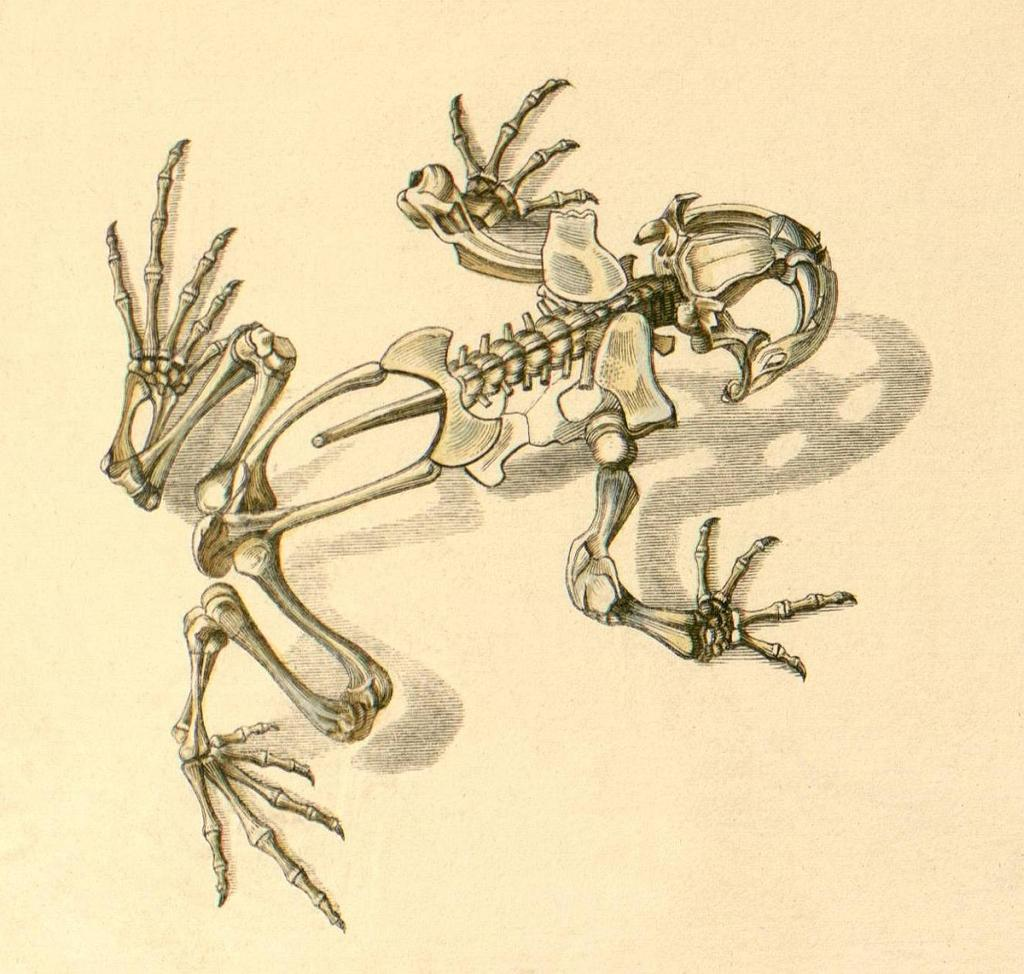What is depicted in the image? There is a drawing of a frog's skeleton in the image. What color is the background of the image? The background of the image is cream-colored. What is the reaction of the frog to the expansion of the universe in the image? There is no frog or expansion of the universe depicted in the image; it only features a drawing of a frog's skeleton. 